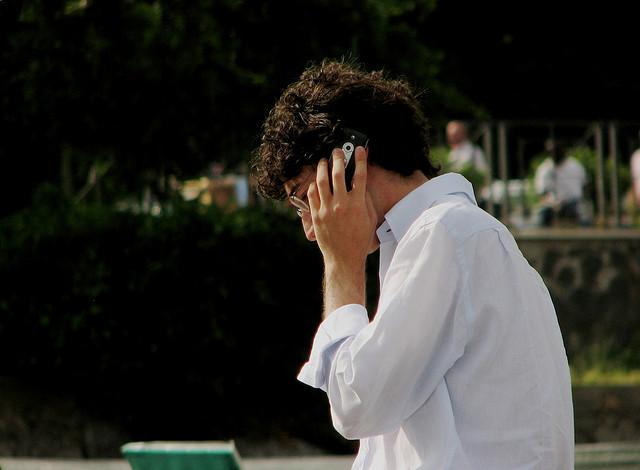Is there anyone who is not wearing a white shirt?
Be succinct. No. Is this man wearing glasses?
Answer briefly. Yes. Is the guy talking on a cell phone?
Quick response, please. Yes. Is it night time?
Write a very short answer. No. 